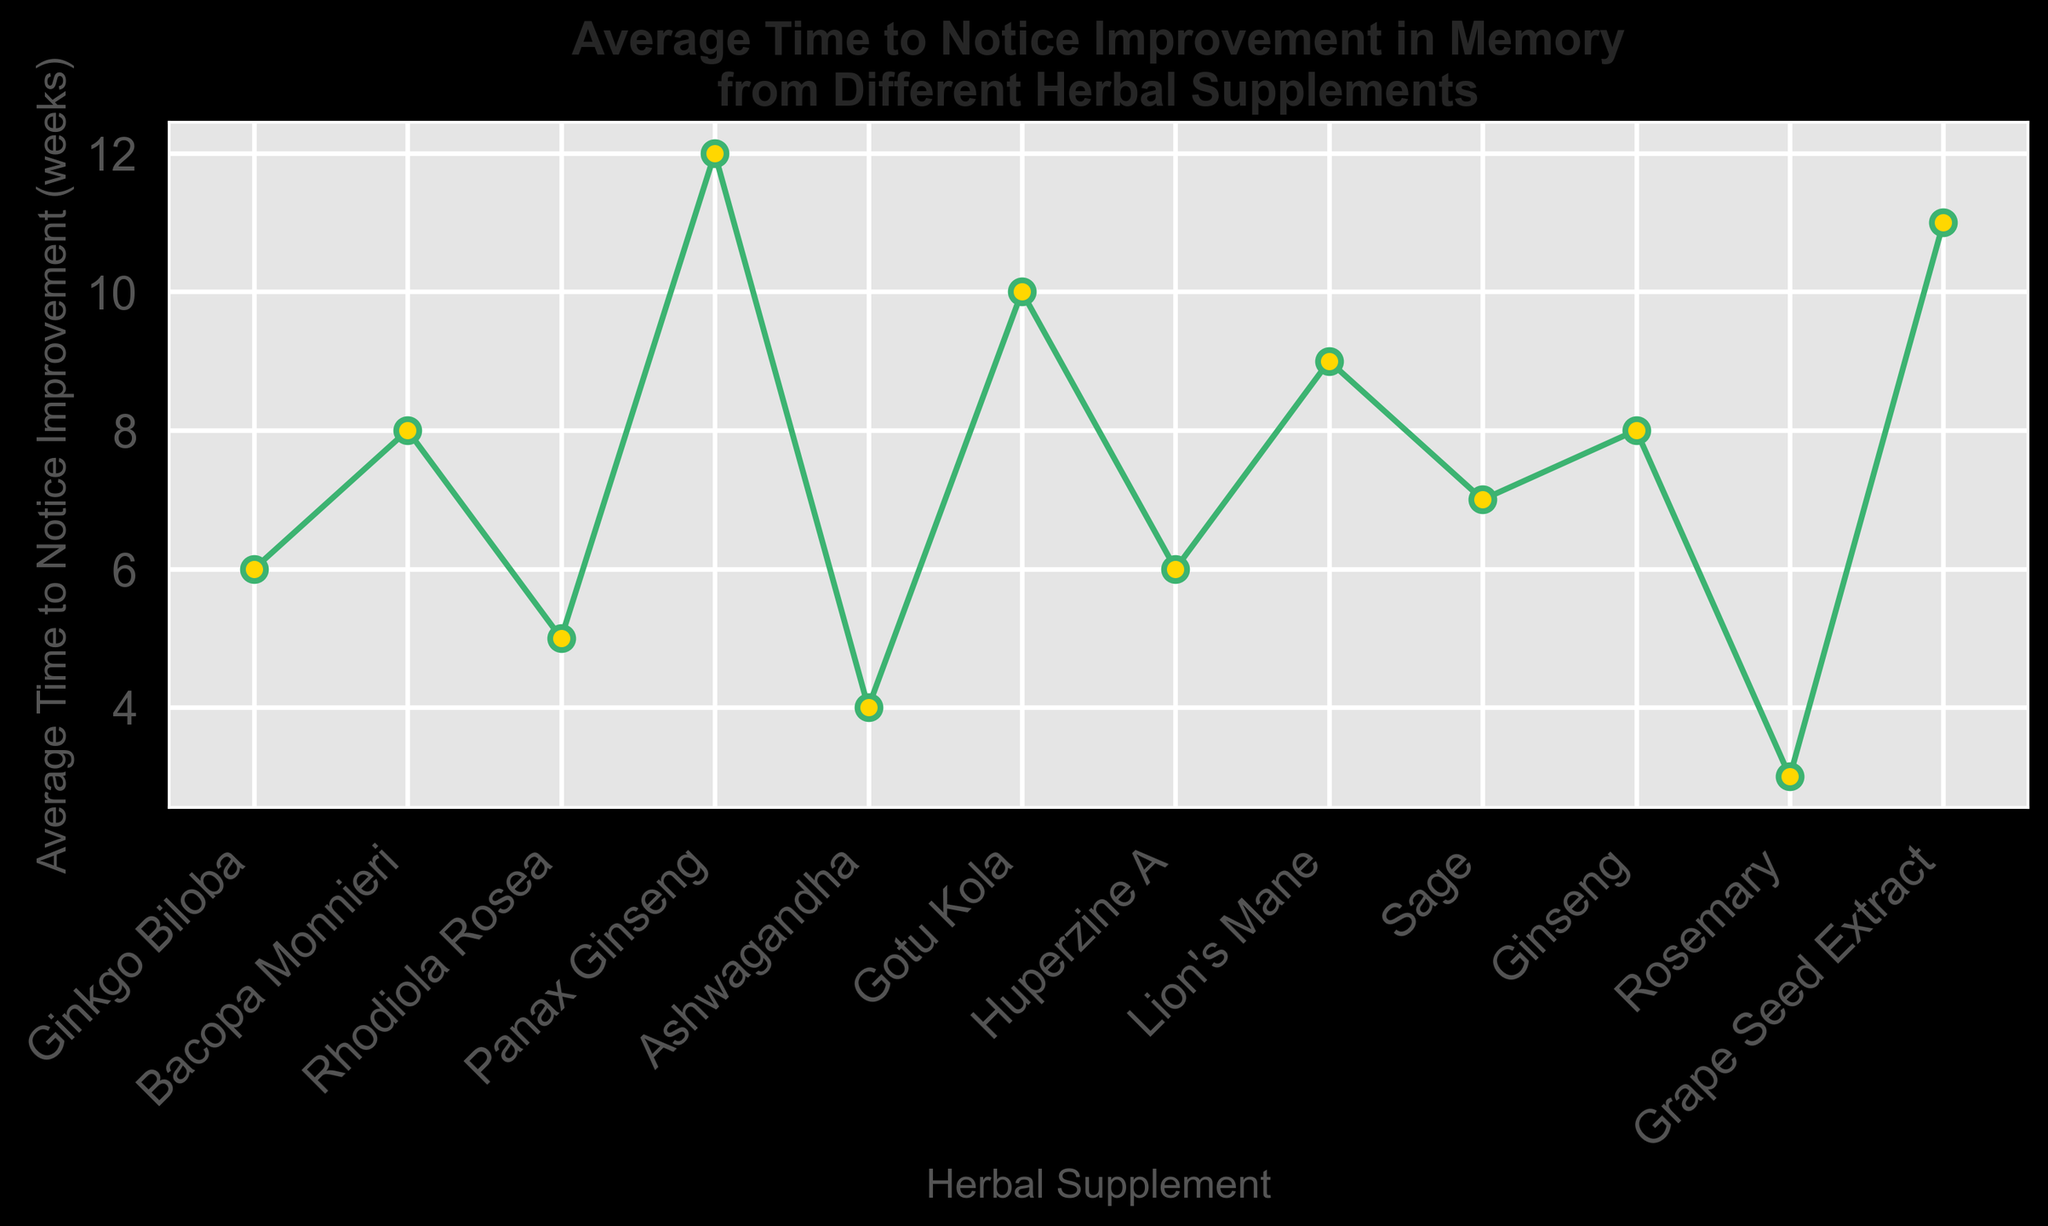Which herbal supplement takes the shortest time to notice improvement? By looking at the y-axis values and the positions of the markers, Rosemary has the lowest value, indicating it takes the shortest time.
Answer: Rosemary Which herbal supplement takes the longest time to notice improvement? By looking at the y-axis values and the positions of the markers, Panax Ginseng has the highest value, indicating it takes the longest time.
Answer: Panax Ginseng What is the average time to notice improvement for Ginkgo Biloba and Huperzine A combined? First, identify the values for Ginkgo Biloba (6 weeks) and Huperzine A (6 weeks). Sum these values (6 + 6 = 12) and then divide by 2 to find the average (12/2 = 6).
Answer: 6 weeks How much longer does it take to notice improvement with Gotu Kola compared to Ashwagandha? Identify the values for Gotu Kola (10 weeks) and Ashwagandha (4 weeks) and calculate the difference (10 - 4 = 6).
Answer: 6 weeks Which herbal supplement takes exactly 9 weeks to show improvement? By checking the y-axis values corresponding to the herbal supplements, Lion's Mane shows an improvement at exactly 9 weeks.
Answer: Lion's Mane Is the average time to notice improvement for Ginseng higher or lower than Sage? Compare the values for Ginseng (8 weeks) and Sage (7 weeks). Ginseng has a higher value than Sage.
Answer: Higher What is the total time to notice improvement when using Bacopa Monnieri, Sage, and Grape Seed Extract combined? Add the values for Bacopa Monnieri (8 weeks), Sage (7 weeks), and Grape Seed Extract (11 weeks): 8 + 7 + 11 = 26.
Answer: 26 weeks Which supplement shows improvement faster, Rhodiola Rosea or Gotu Kola? By comparing the values for Rhodiola Rosea (5 weeks) and Gotu Kola (10 weeks), Rhodiola Rosea shows improvement faster.
Answer: Rhodiola Rosea How many supplements have an average time to notice improvement of 6 weeks or less? Identify and count the supplements with values less than or equal to 6: Ginkgo Biloba (6 weeks), Rhodiola Rosea (5 weeks), Ashwagandha (4 weeks), Huperzine A (6 weeks), and Rosemary (3 weeks). There are 5 such supplements.
Answer: 5 